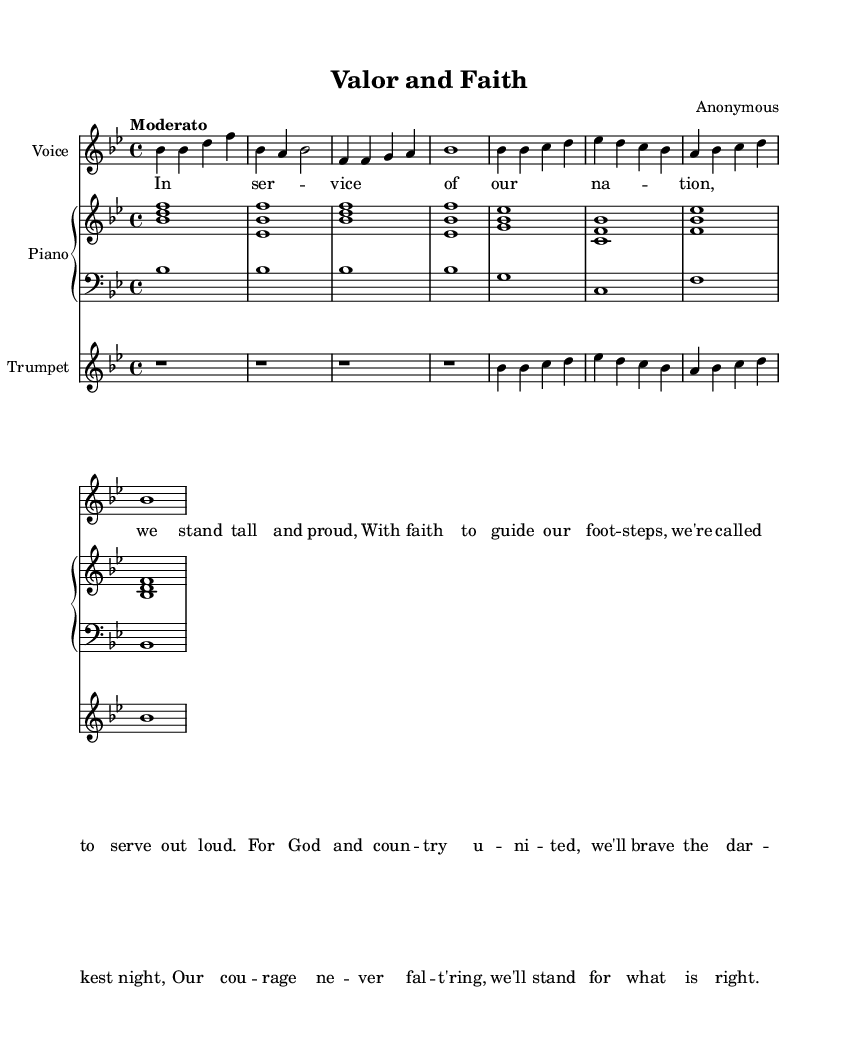What is the key signature of this music? The key signature is indicated at the beginning of the staff and determines the pitch of the notes. In this case, there are two flats shown, which means the key signature is B flat major.
Answer: B flat major What is the time signature of this music? The time signature is found at the beginning of the staff and indicates how many beats are in each measure. Here, it shows a 4 over 4, meaning there are four beats in each measure, which is common in many musical styles.
Answer: 4/4 What is the tempo marking for this piece? The tempo marking is specified in the score, usually indicated by the word "Moderato," which suggests a moderate speed for the performance of the piece.
Answer: Moderato How many measures are in the piece? By counting the vertical lines that separate sections of music (bar lines), one can determine the number of measures. There are eight measures in total as indicated in the score.
Answer: Eight What is the role of the trumpet in this piece? The trumpet plays as a separate melody instrument, indicated by its own staff in the score. It's often used in religious or patriotic music to add a powerful and uplifting sound, as shown in the vocal and piano accompaniment.
Answer: Melody What do the lyrics emphasize in this piece? The lyrics reflect themes of service, faith, and courage, highlighting the moral motivations for serving the nation, which is a hallmark of religious patriotic music. This can be gathered by reading through the lyrics provided and their respective emotions.
Answer: Service, faith, courage How does the musical structure support the theme of the piece? The structure includes a vocal melody supported by piano and trumpet arrangements, enhancing the emotional weight of the lyrics. The simple yet powerful arrangement underlines the religious and patriotic themes throughout the piece.
Answer: Vocal melody, piano, trumpet 